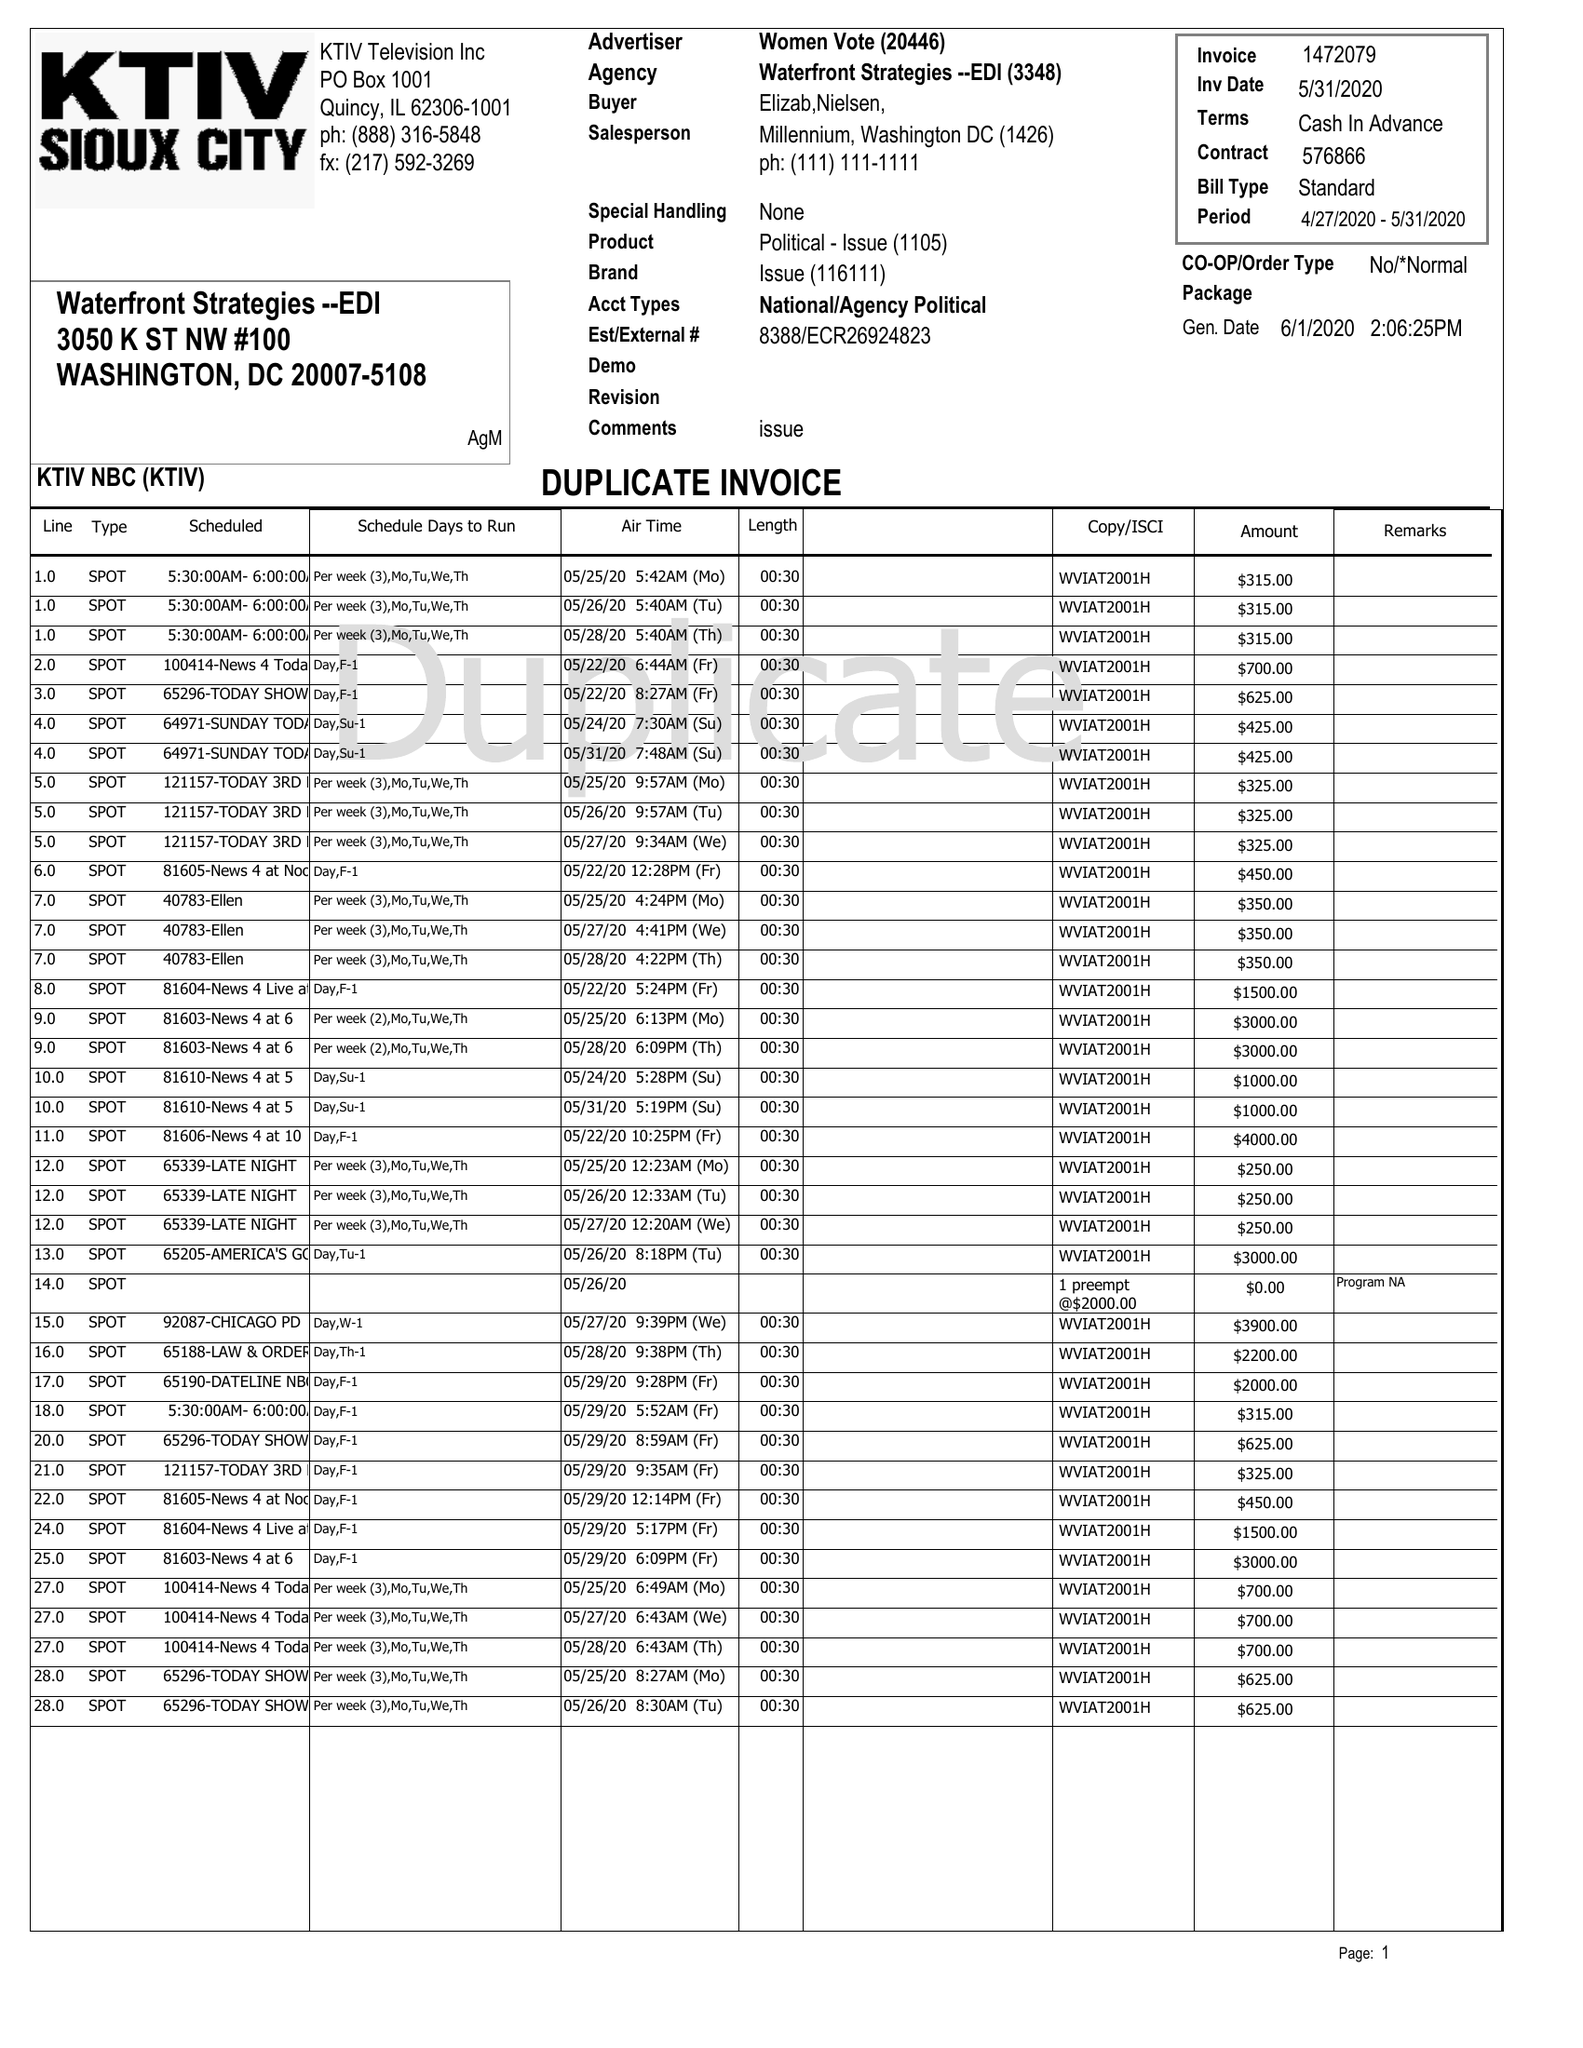What is the value for the gross_amount?
Answer the question using a single word or phrase. 140.00 